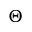<formula> <loc_0><loc_0><loc_500><loc_500>\Theta</formula> 